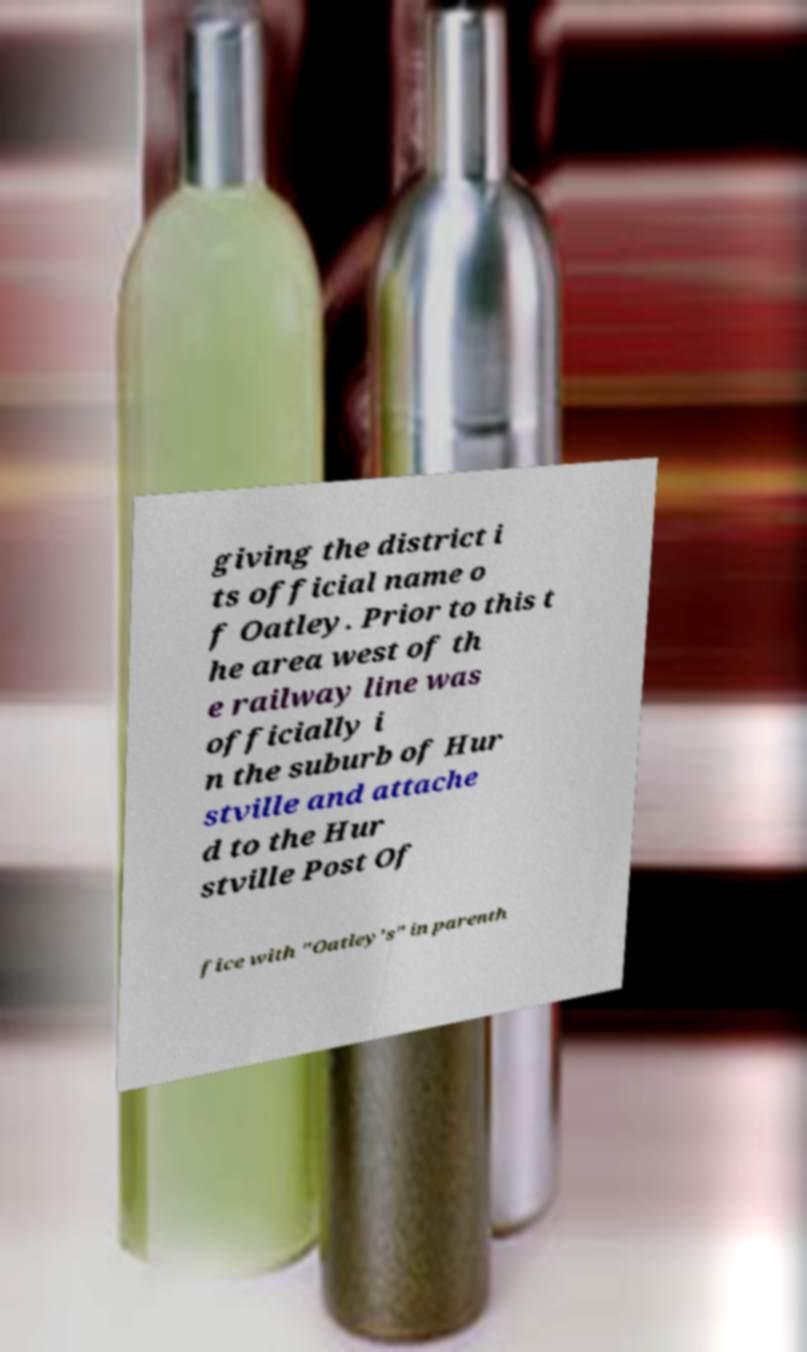Please read and relay the text visible in this image. What does it say? giving the district i ts official name o f Oatley. Prior to this t he area west of th e railway line was officially i n the suburb of Hur stville and attache d to the Hur stville Post Of fice with "Oatley's" in parenth 